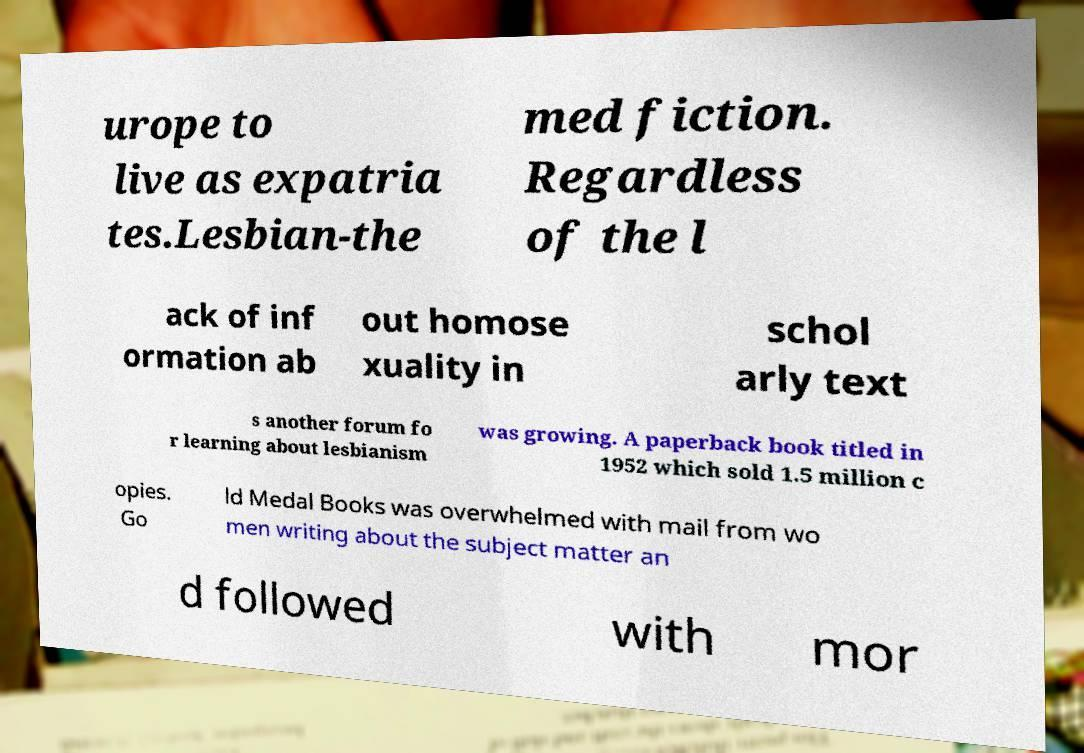For documentation purposes, I need the text within this image transcribed. Could you provide that? urope to live as expatria tes.Lesbian-the med fiction. Regardless of the l ack of inf ormation ab out homose xuality in schol arly text s another forum fo r learning about lesbianism was growing. A paperback book titled in 1952 which sold 1.5 million c opies. Go ld Medal Books was overwhelmed with mail from wo men writing about the subject matter an d followed with mor 